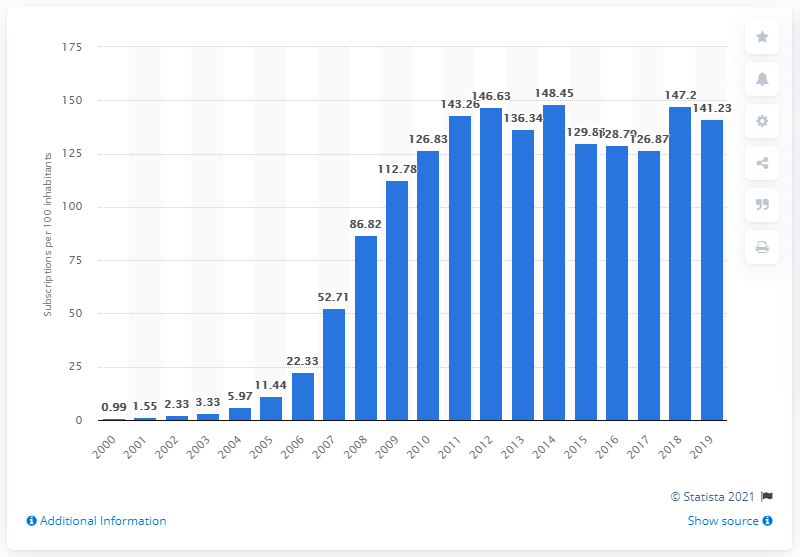Outline some significant characteristics in this image. From 2000 to 2019, there were an average of 141.23 mobile subscriptions for every 100 people in Vietnam. 